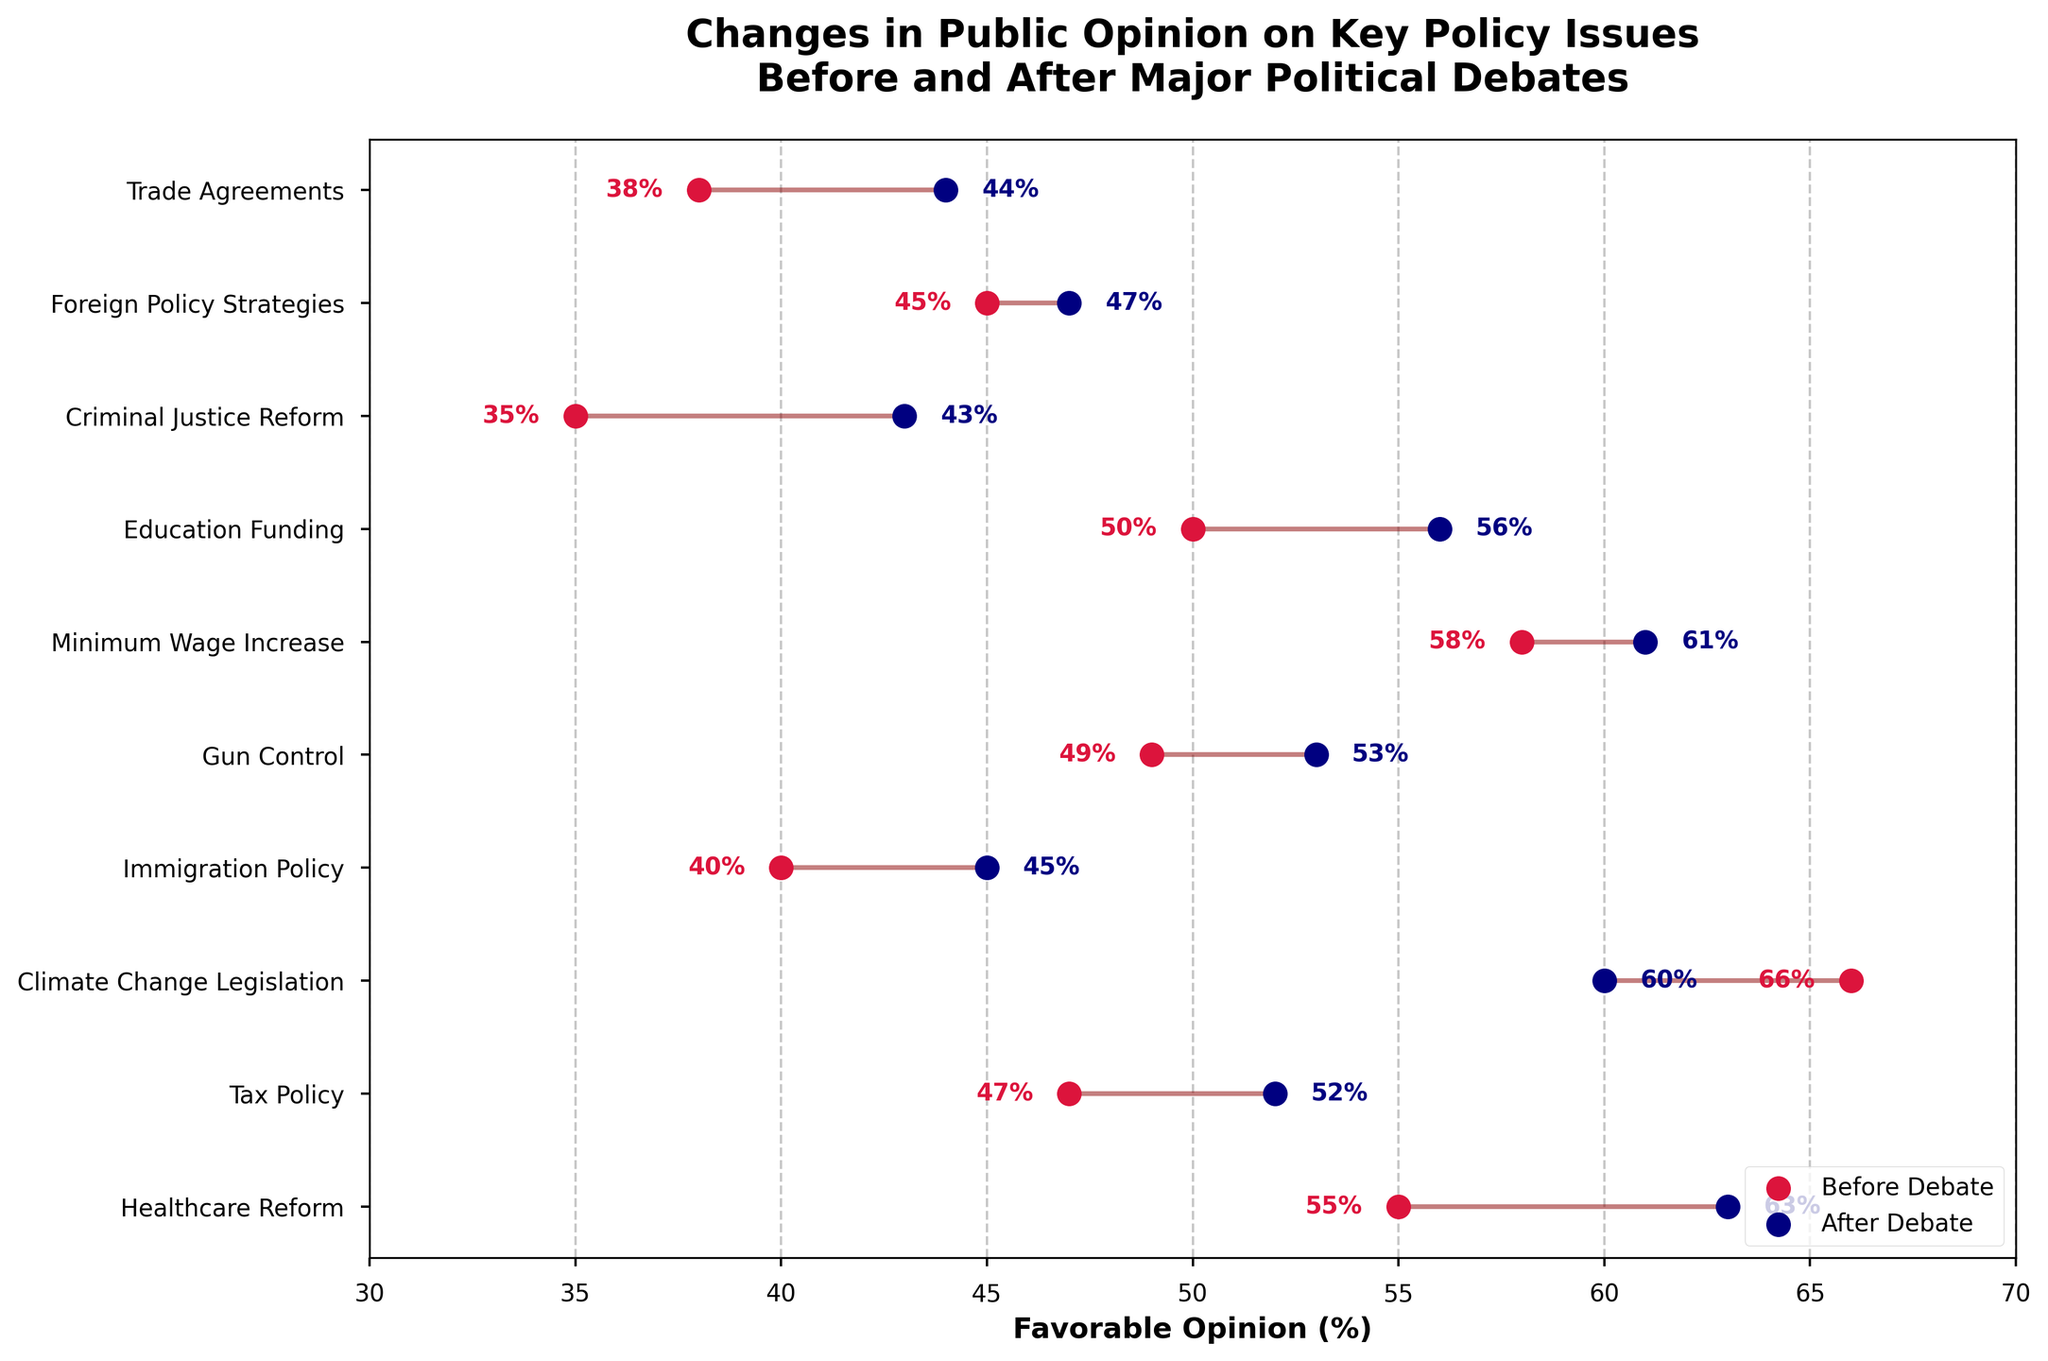Which policy issue saw the largest increase in favorable opinion after the debate? Look at the endpoints of the lines where the After Debate percentage is much higher than the Before Debate percentage. The largest difference is for Criminal Justice Reform, which increased from 35% to 43%.
Answer: Criminal Justice Reform What is the average favorable opinion of all issues before the debate? Sum the percentages before the debate and divide by the number of issues: (55 + 47 + 66 + 40 + 49 + 58 + 50 + 35 + 45 + 38) / 10 = 48.3%.
Answer: 48.3% Which issue has a decrease in favorable opinion after the debate? Compare the Before and After percentages for each issue. Climate Change Legislation decreased from 66% to 60%.
Answer: Climate Change Legislation Which two issues have the smallest change in favorable opinion after the debate? Calculate the absolute differences for each issue. Foreign Policy Strategies changed from 45% to 47% (2%) and Minimum Wage Increase changed from 58% to 61% (3%). These are the smallest changes.
Answer: Foreign Policy Strategies and Minimum Wage Increase What is the range of favorable opinion percentages before the debate? Subtract the lowest percentage before the debate from the highest percentage: 66% (Climate Change Legislation) - 35% (Criminal Justice Reform) = 31%.
Answer: 31% How did favorable opinion on Immigration Policy change after the debate? Check the percentages for Immigration Policy before and after the debate, it increased from 40% to 45%.
Answer: Increased by 5% Which issue had the highest favorable opinion after the debate? Look for the highest percentage in the After Debate column. Healthcare Reform is the highest at 63%.
Answer: Healthcare Reform If the favorable opinion on Foreign Policy Strategies increased to 50% after the debate, what would be the new average favorable opinion for all issues after the debate? Replace the existing 47% for Foreign Policy Strategies with 50%, then sum up the new percentages and divide by 10: (63 + 52 + 60 + 45 + 53 + 61 + 56 + 43 + 50 + 44) / 10 = 52.7%.
Answer: 52.7% 